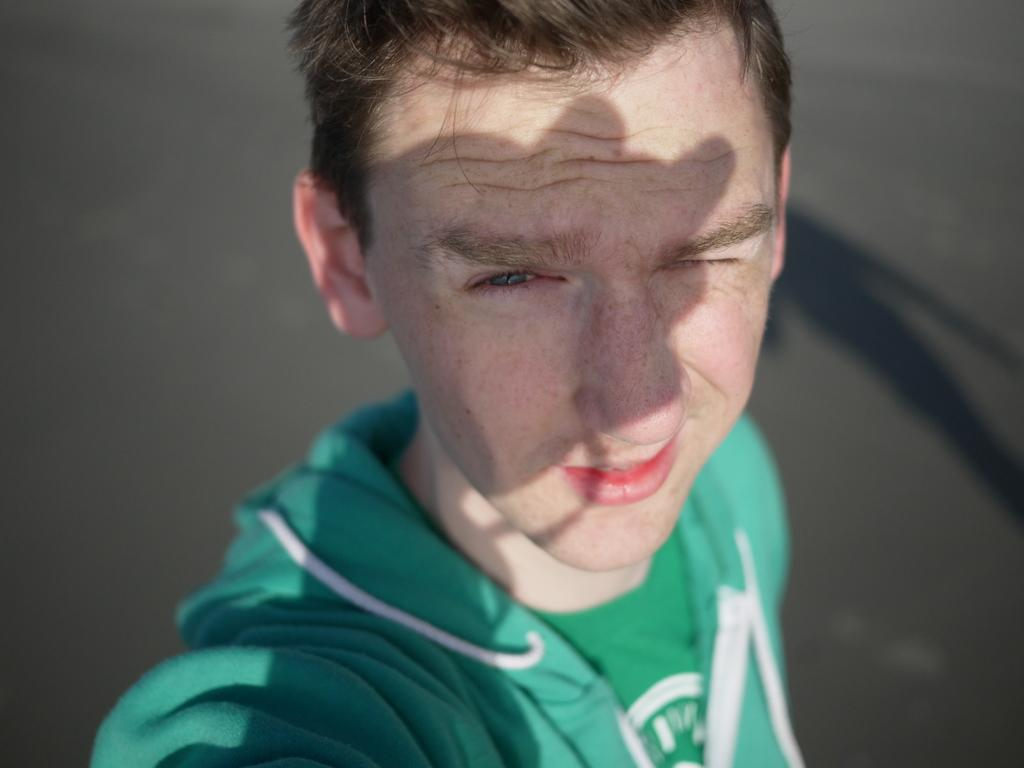Who or what is the main subject in the image? There is a person in the image. What is the person wearing? The person is wearing a green and white colored dress. What can be seen in the background of the image? There is ground visible in the background of the image. What grade did the person receive for their performance in the image? There is no indication of a performance or grade in the image; it simply shows a person wearing a green and white colored dress with ground visible in the background. 